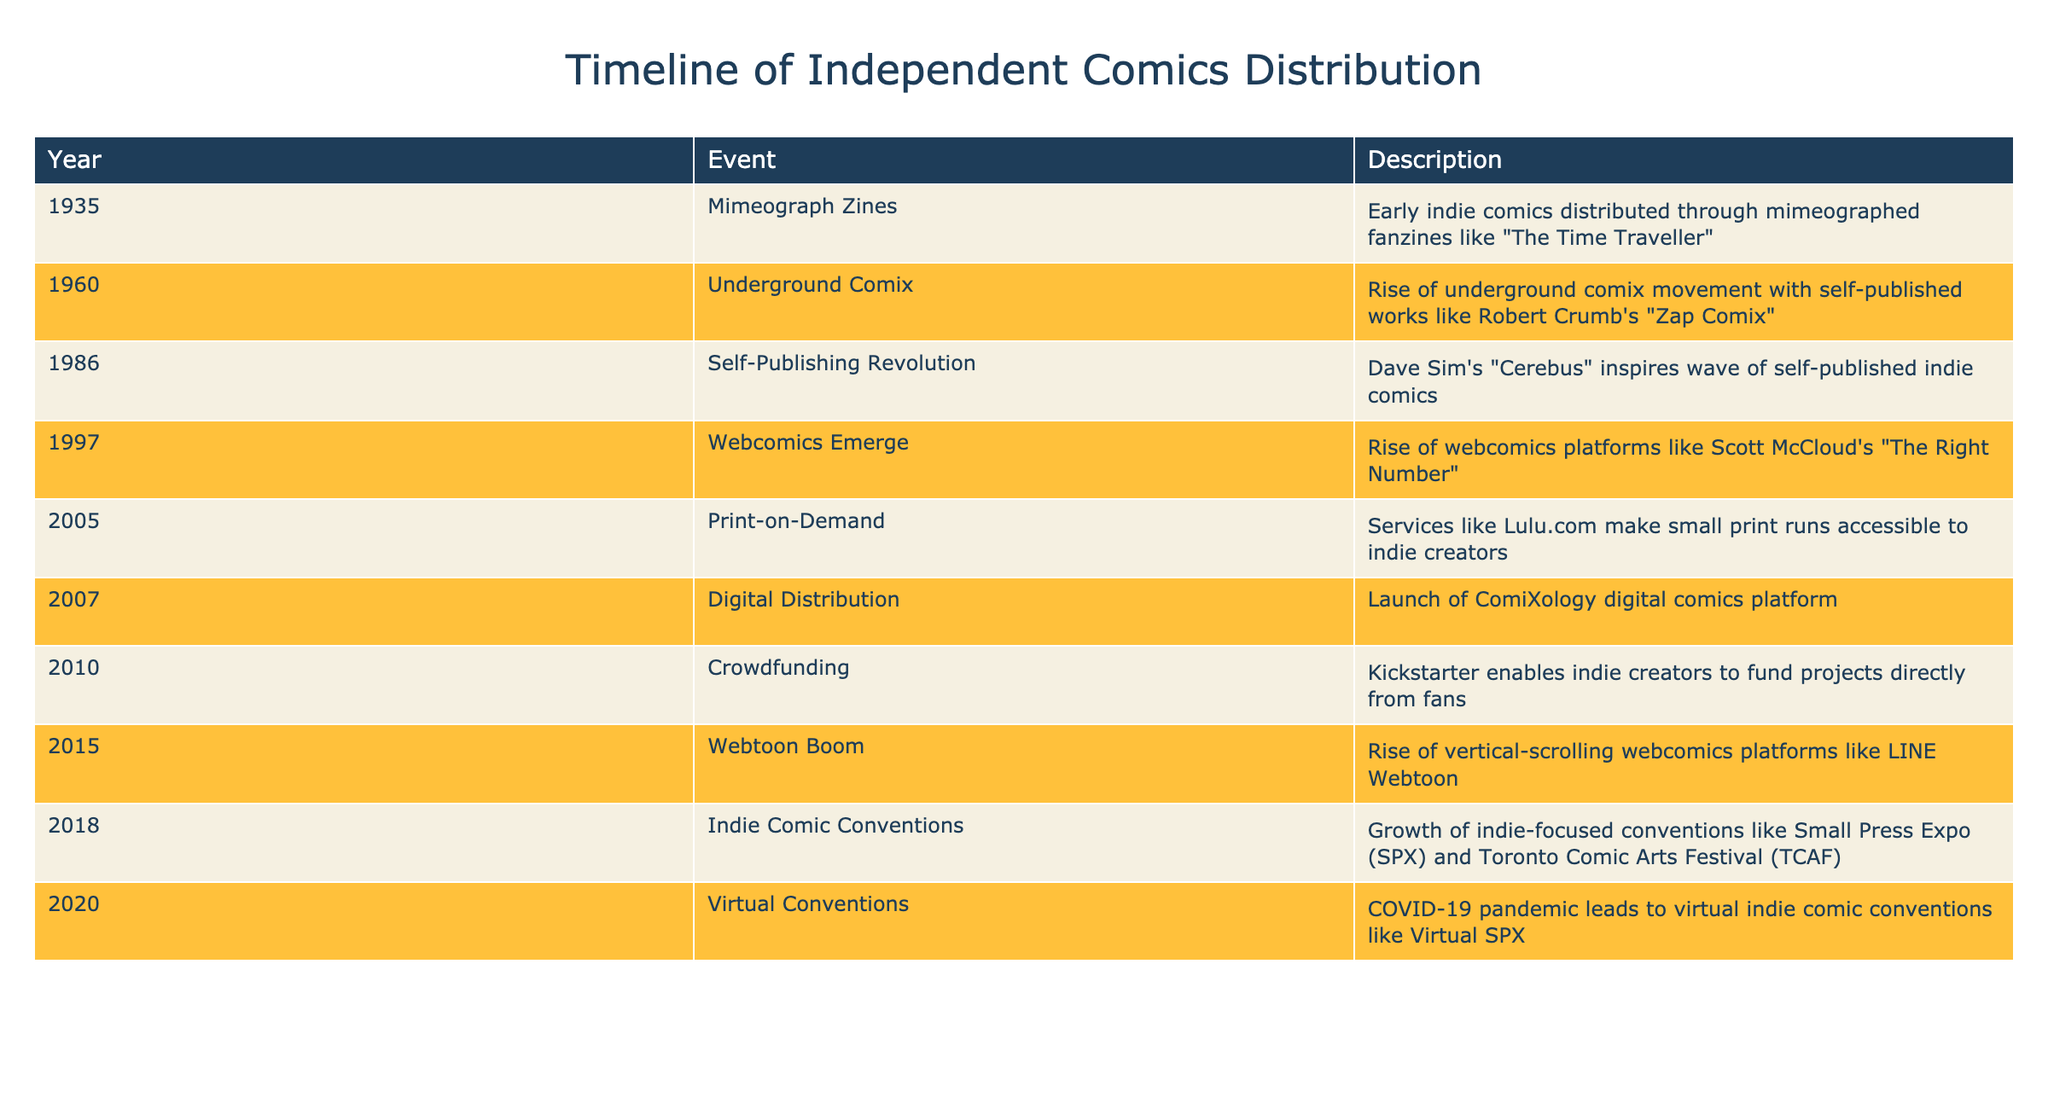What year did the underground comix movement begin? The table shows that the underground comix movement began in 1960. This is directly stated in the "Year" column alongside the "Event" column that indicates the underground comix movement’s rise.
Answer: 1960 What event occurred in 1986? According to the table, the event in 1986 was the "Self-Publishing Revolution." This can be found directly in the "Year" column for that specific year.
Answer: Self-Publishing Revolution How many years passed between the emergence of webcomics in 1997 and the launch of ComiXology in 2007? From 1997 to 2007, there are 10 years. This can be calculated by subtracting 1997 from 2007 (2007 - 1997 = 10).
Answer: 10 Was the rise of virtual conventions due to the COVID-19 pandemic? The table indicates that in 2020, virtual conventions emerged as a result of the COVID-19 pandemic, affirming this statement to be true.
Answer: Yes Which two events are related to digital distribution methods, and in what years did they occur? The table lists "Digital Distribution" in 2007 and "Webcomics Emerge" in 1997 as related events concerning digital distribution methods. Both years can be cumulatively analyzed to show the development of digital distribution in independent comics.
Answer: 1997 and 2007 What was the first known method for distributing independent comics mentioned in this table? Referring to the table, "Mimeograph Zines" in 1935 is the first method of independent comics distribution detailed in the data. This is captured under the first entry in the timeline.
Answer: Mimeograph Zines How many major shifts toward self-publishing are mentioned from the 1980s to 2000s? The events listed are the "Self-Publishing Revolution" in 1986 and "Crowdfunding" in 2010. Counting these, we see two major shifts towards self-publishing.
Answer: 2 List the years when webcomic platforms became prominent, according to the table. Based on the information in the table, webcomic platforms became notably prominent in 1997 with the emergence of webcomics and again in 2015 during the Webtoon boom. These two years highlight the significant shifts towards webcomic distribution methods.
Answer: 1997 and 2015 In which year did indie comic conventions grow, according to the timeline? The table indicates that the growth of indie-focused conventions occurred in 2018. This is noted clearly in the "Year" column next to the respective event description.
Answer: 2018 